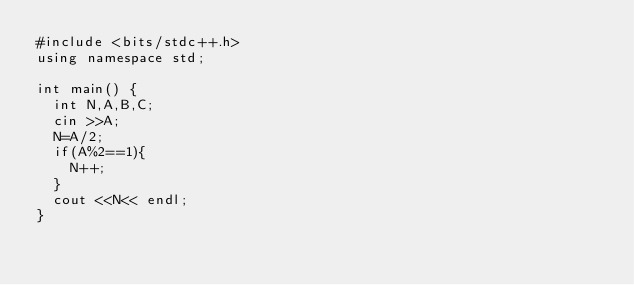Convert code to text. <code><loc_0><loc_0><loc_500><loc_500><_C++_>#include <bits/stdc++.h>
using namespace std;

int main() {
  int N,A,B,C;
  cin >>A;
  N=A/2;
  if(A%2==1){
    N++;
  }
  cout <<N<< endl;
}
</code> 